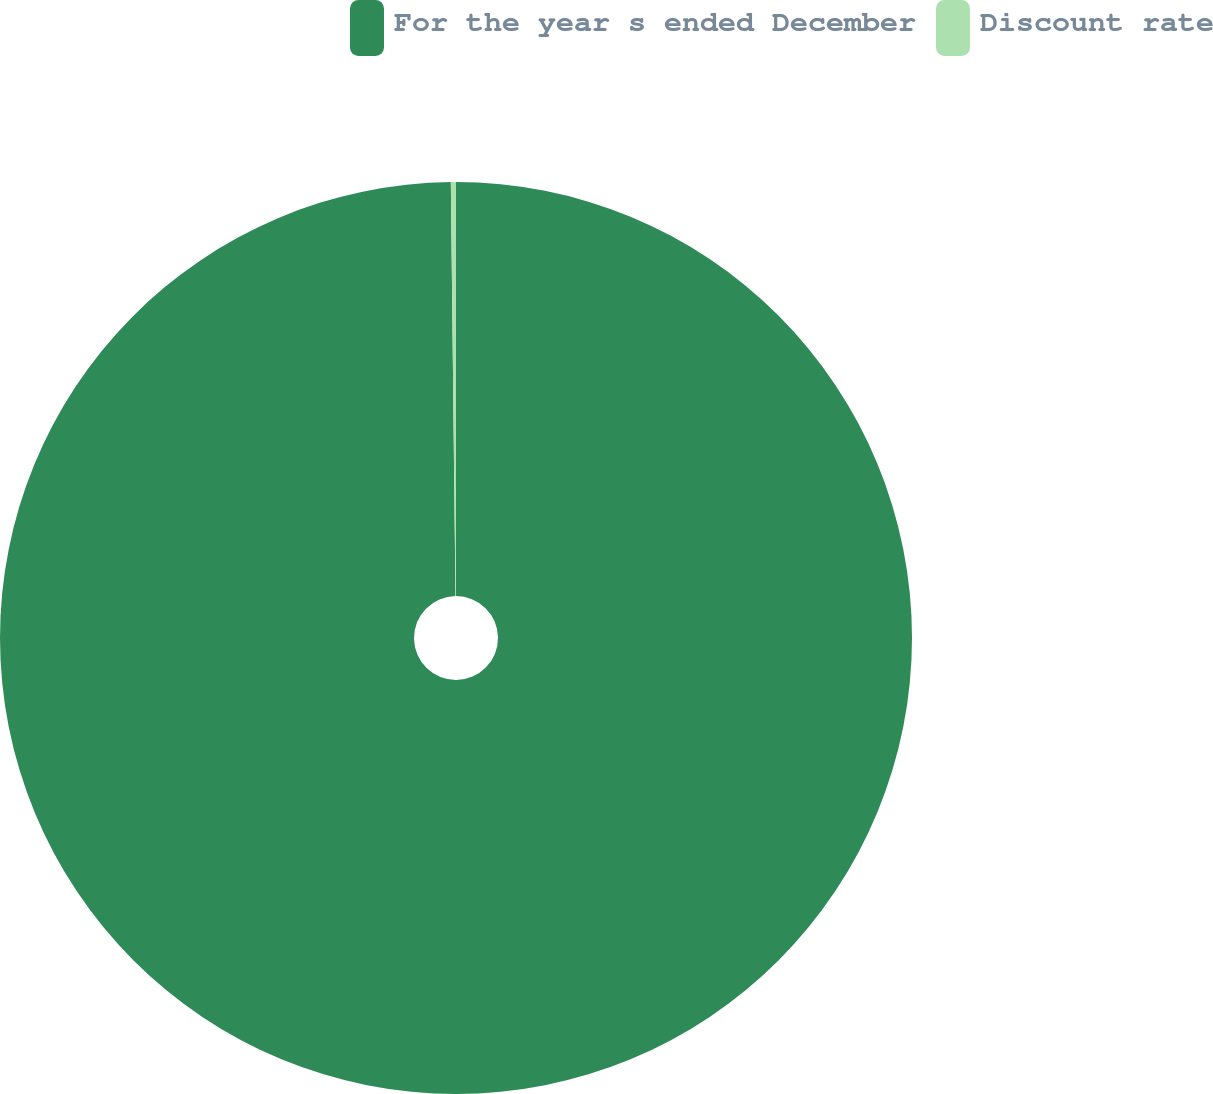Convert chart. <chart><loc_0><loc_0><loc_500><loc_500><pie_chart><fcel>For the year s ended December<fcel>Discount rate<nl><fcel>99.82%<fcel>0.18%<nl></chart> 